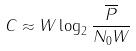<formula> <loc_0><loc_0><loc_500><loc_500>C \approx W \log _ { 2 } \frac { \overline { P } } { N _ { 0 } W }</formula> 